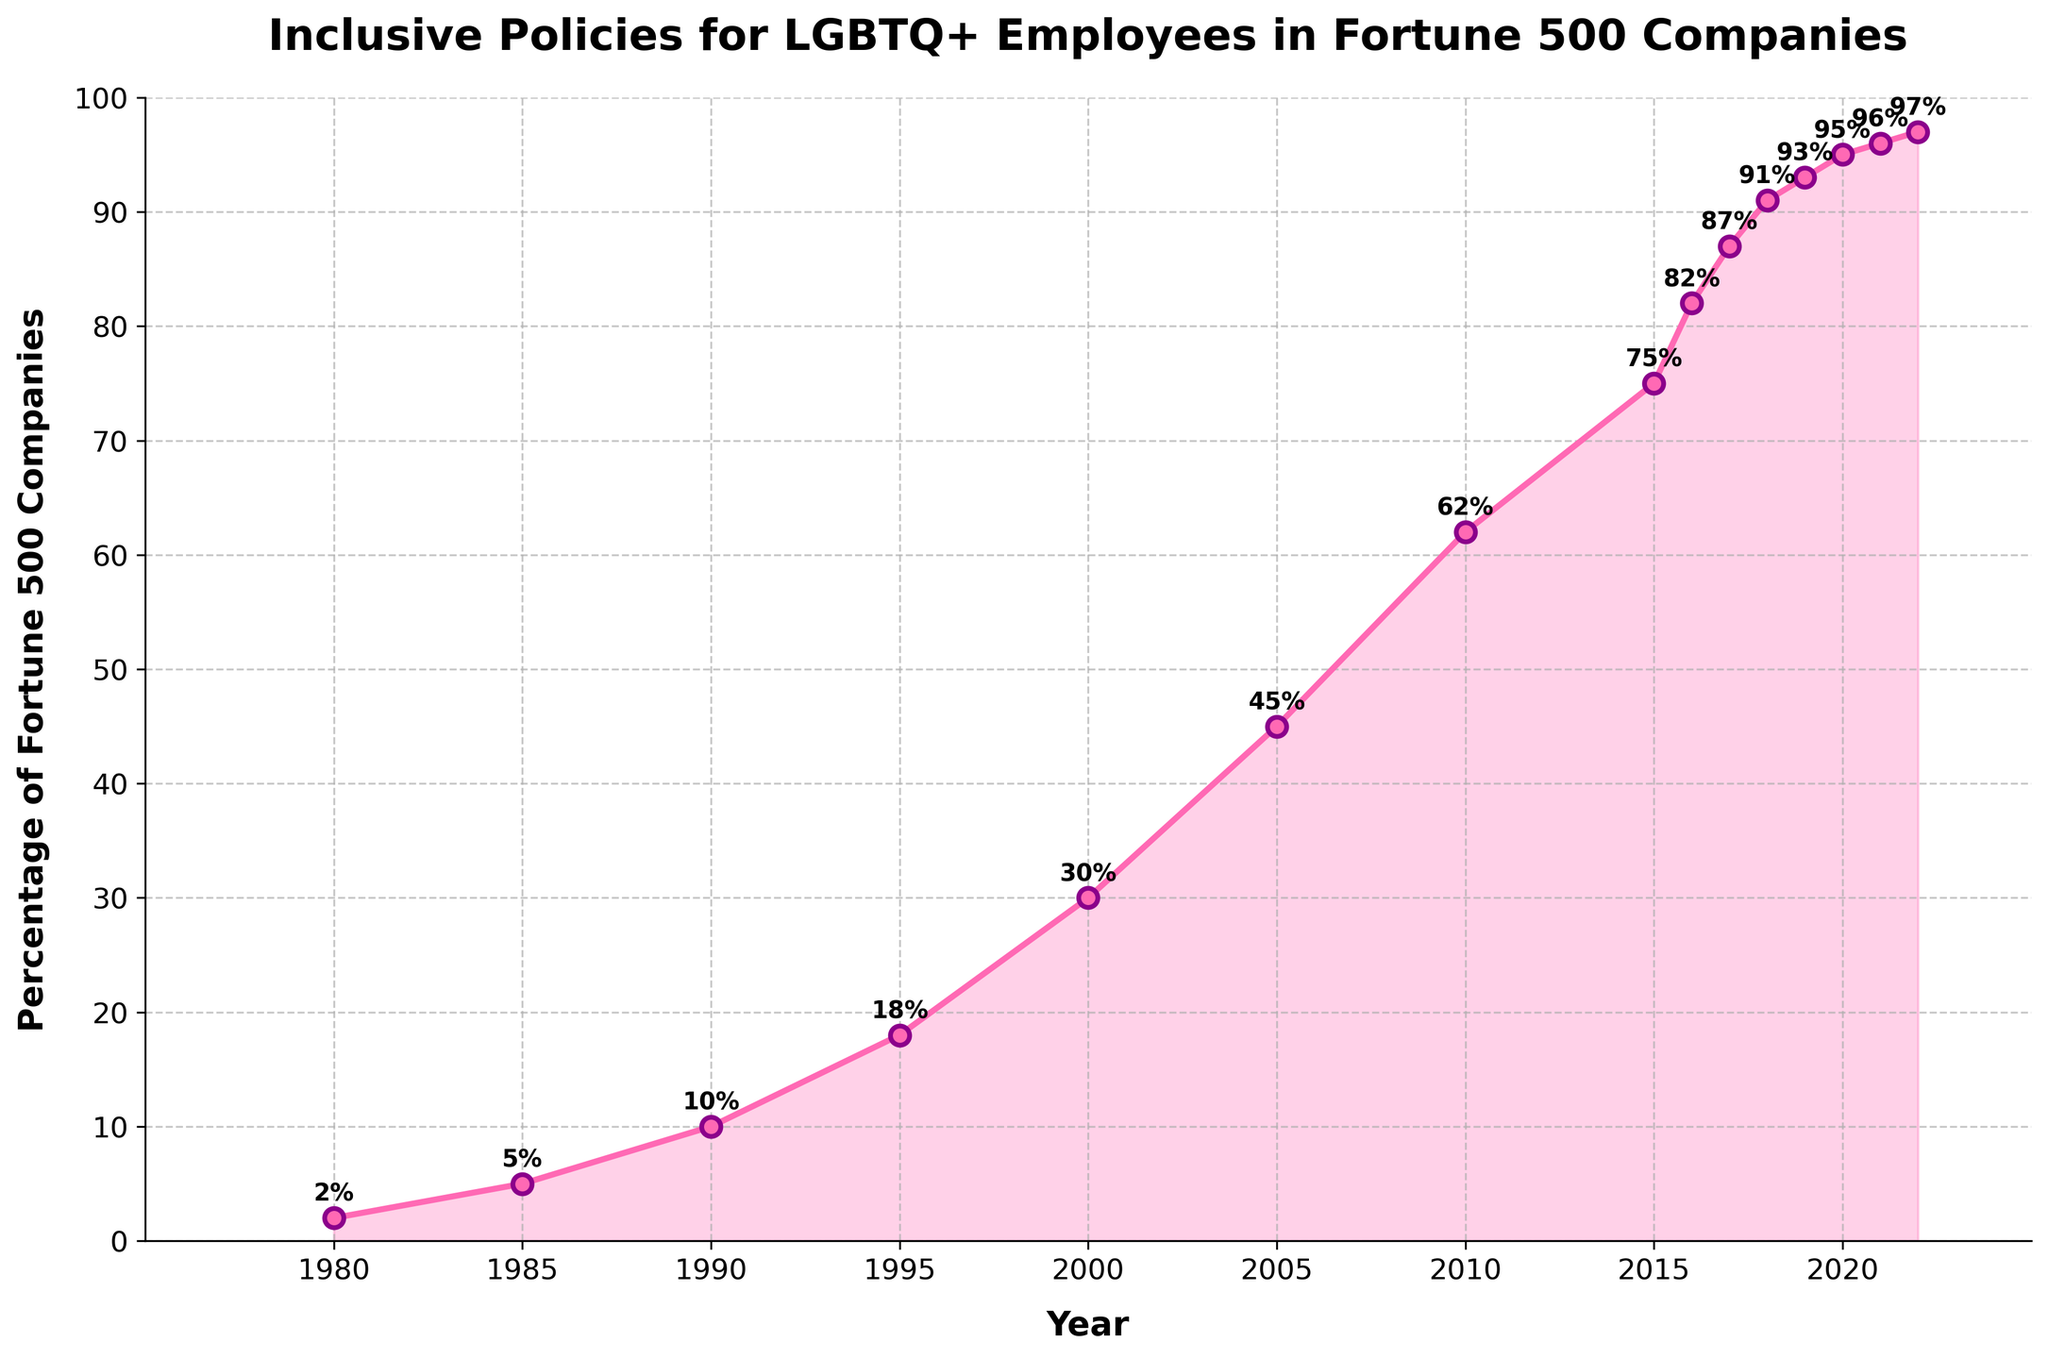What is the percentage of Fortune 500 companies with inclusive policies for LGBTQ+ employees in 1995? Observe the data point for the year 1995. The annotated percentage is 18%.
Answer: 18% Between which two consecutive years did the largest increase in the percentage of Fortune 500 companies with inclusive policies for LGBTQ+ employees occur? Compare the percentage increase between each consecutive pair of years and identify the largest increase. The largest increase was from 2000 to 2005, where it increased from 30% to 45%, a difference of 15%.
Answer: 2000 to 2005 What was the percentage increase from 1980 to 2022? Subtract the 1980 percentage (2%) from the 2022 percentage (97%) to find the increase. 97% - 2% = 95%.
Answer: 95% At what rate does the percentage of inclusive policies increase per decade from 1980 to 2020? Calculate the difference for each decade: 1980-1990 (10% - 2% = 8%), 1990-2000 (30% - 10% = 20%), 2000-2010 (62% - 30% = 32%), 2010-2020 (95% - 62% = 33%). Then calculate the average increase per decade: (8% + 20% + 32% + 33%)/4 = 23.25%.
Answer: 23.25% How does the percentage in 2015 compare to that in 2010? Subtract the 2010 percentage (62%) from the 2015 percentage (75%) to find the difference. 75% - 62% = 13%. So, the percentage increased by 13% between 2010 and 2015.
Answer: 13% What is the trend observed in the percentage of Fortune 500 companies with inclusive policies for LGBTQ+ employees from 2017 to 2022? Note the percentages from 2017 to 2022: 87%, 91%, 93%, 95%, 96%, 97%. The trend shows a steady increment over these years.
Answer: Steady increment What's the average percentage of Fortune 500 companies with inclusive policies from 1980 to 2000? Add the percentages for 1980 (2%), 1985 (5%), 1990 (10%), 1995 (18%), and 2000 (30%). Then, divide by the number of years (5): (2% + 5% + 10% + 18% + 30%) / 5 = 13%.
Answer: 13% At what percentage did the Fortune 500 companies' inclusive policies reach a majority (greater than 50%)? Check the data points to find the year when the percentage exceeded 50%. This occurred in 2005 with 62%.
Answer: 2005 How many years did it take for the percentage to reach 75% from an initial 2% in 1980? The initial percentage was 2% in 1980, and it reached 75% in 2015. The number of years between 1980 and 2015 is 2015 - 1980 = 35 years.
Answer: 35 years Is the increase in the percentage of inclusive Fortune 500 companies faster in the earlier years (1980-2000) or the later years (2000-2020)? Calculate the percentage increase in both periods: (2000: 30% - 1980: 2% = 28%) and (2020: 95% - 2000: 30% = 65%). The increase from 2000 to 2020 is faster.
Answer: Later years (2000-2020) 